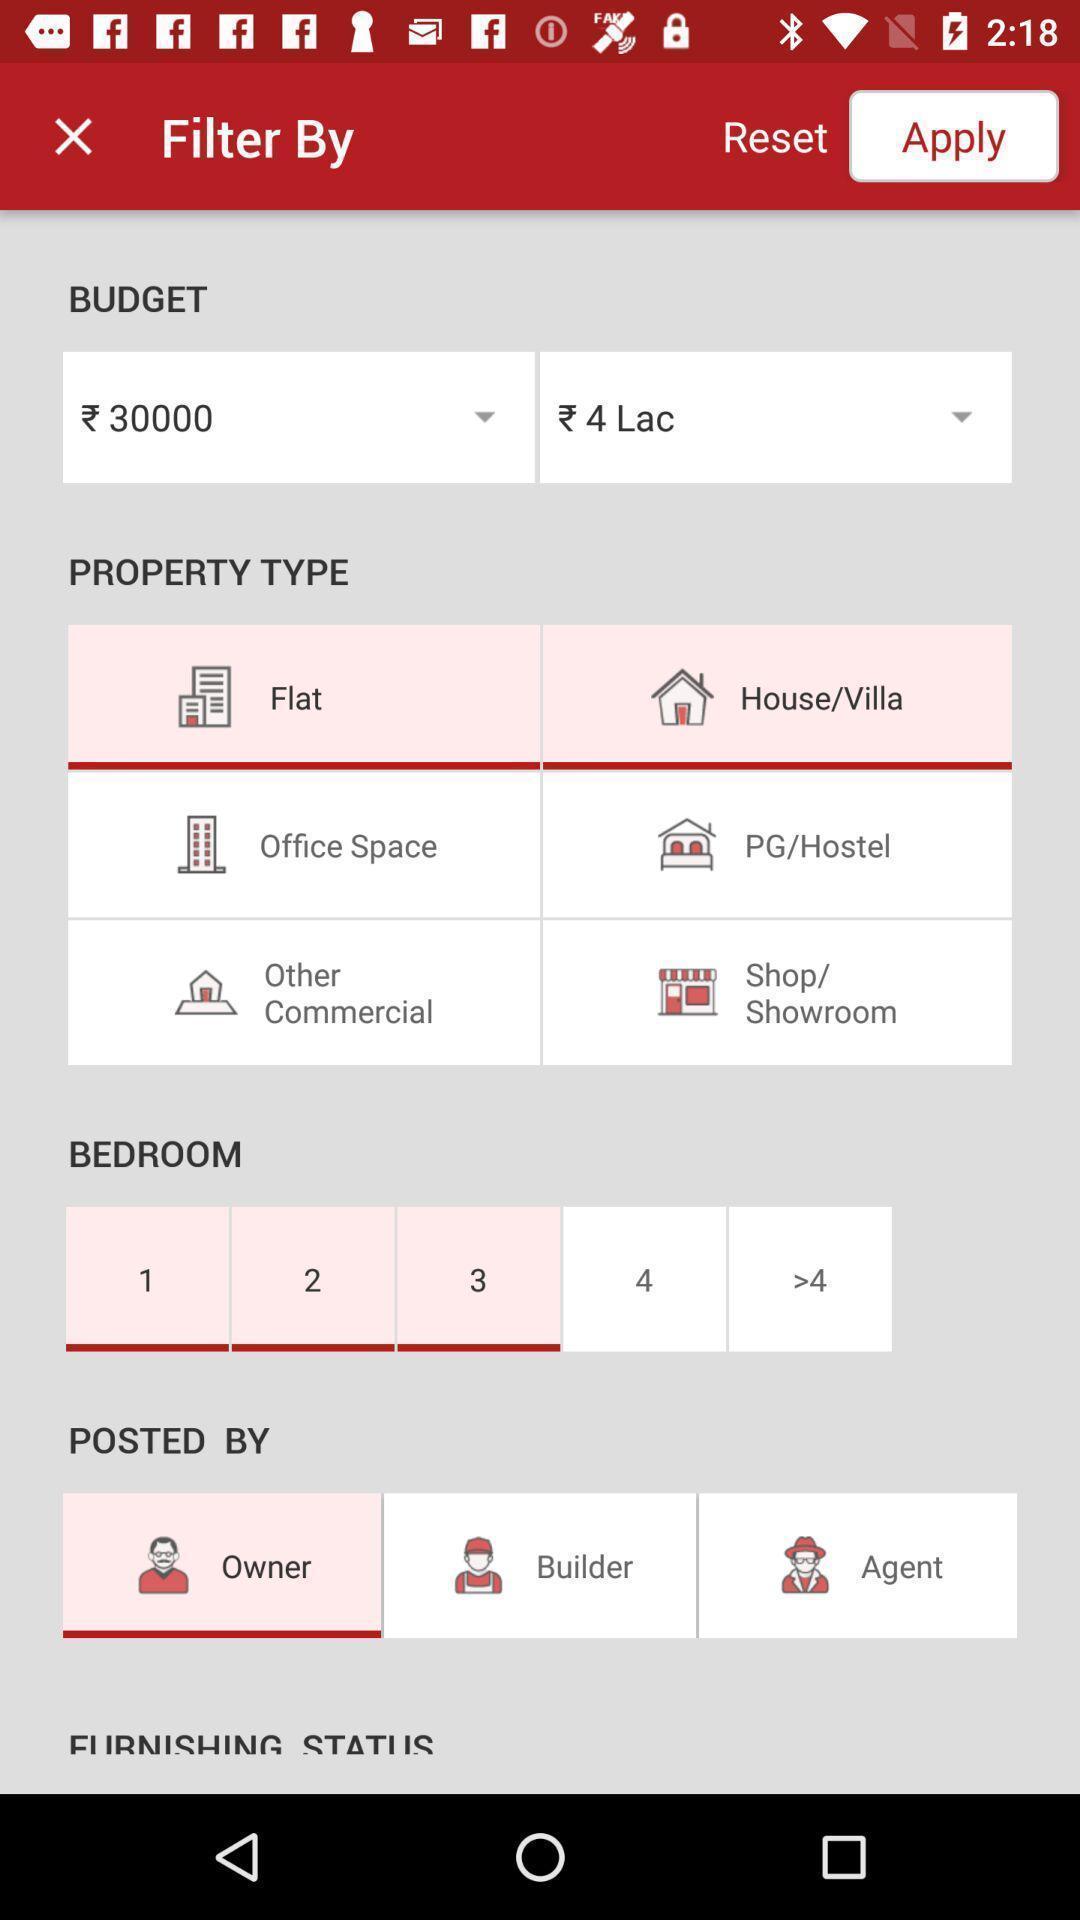Provide a detailed account of this screenshot. Page displaying on filtration of details. 